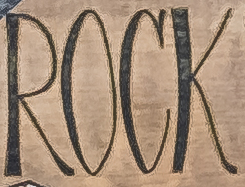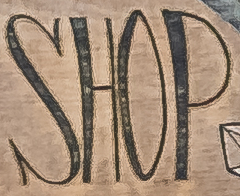What text appears in these images from left to right, separated by a semicolon? ROCK; SHOP 